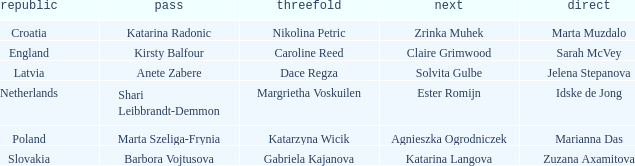Can you give me this table as a dict? {'header': ['republic', 'pass', 'threefold', 'next', 'direct'], 'rows': [['Croatia', 'Katarina Radonic', 'Nikolina Petric', 'Zrinka Muhek', 'Marta Muzdalo'], ['England', 'Kirsty Balfour', 'Caroline Reed', 'Claire Grimwood', 'Sarah McVey'], ['Latvia', 'Anete Zabere', 'Dace Regza', 'Solvita Gulbe', 'Jelena Stepanova'], ['Netherlands', 'Shari Leibbrandt-Demmon', 'Margrietha Voskuilen', 'Ester Romijn', 'Idske de Jong'], ['Poland', 'Marta Szeliga-Frynia', 'Katarzyna Wicik', 'Agnieszka Ogrodniczek', 'Marianna Das'], ['Slovakia', 'Barbora Vojtusova', 'Gabriela Kajanova', 'Katarina Langova', 'Zuzana Axamitova']]} Which lead has Kirsty Balfour as second? Sarah McVey. 